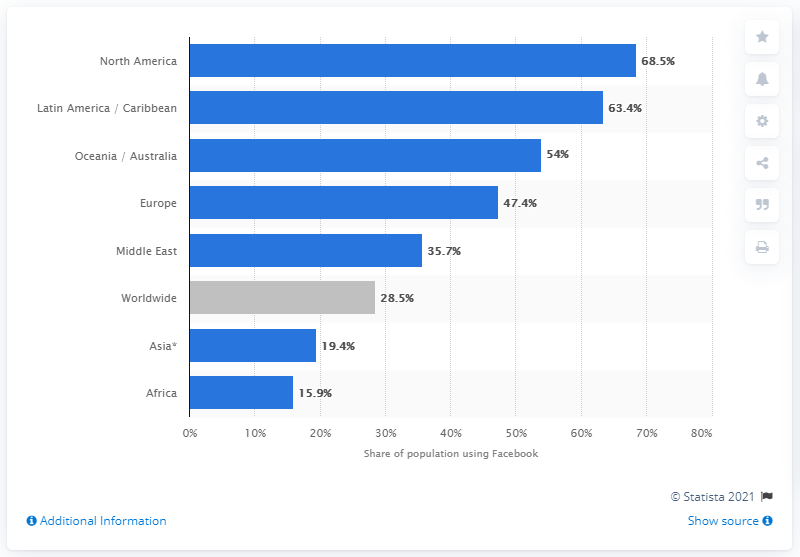Draw attention to some important aspects in this diagram. The country with the lowest Facebook penetration rate is Africa. As of 2021, the global penetration rate of Facebook was approximately 28.5%. 